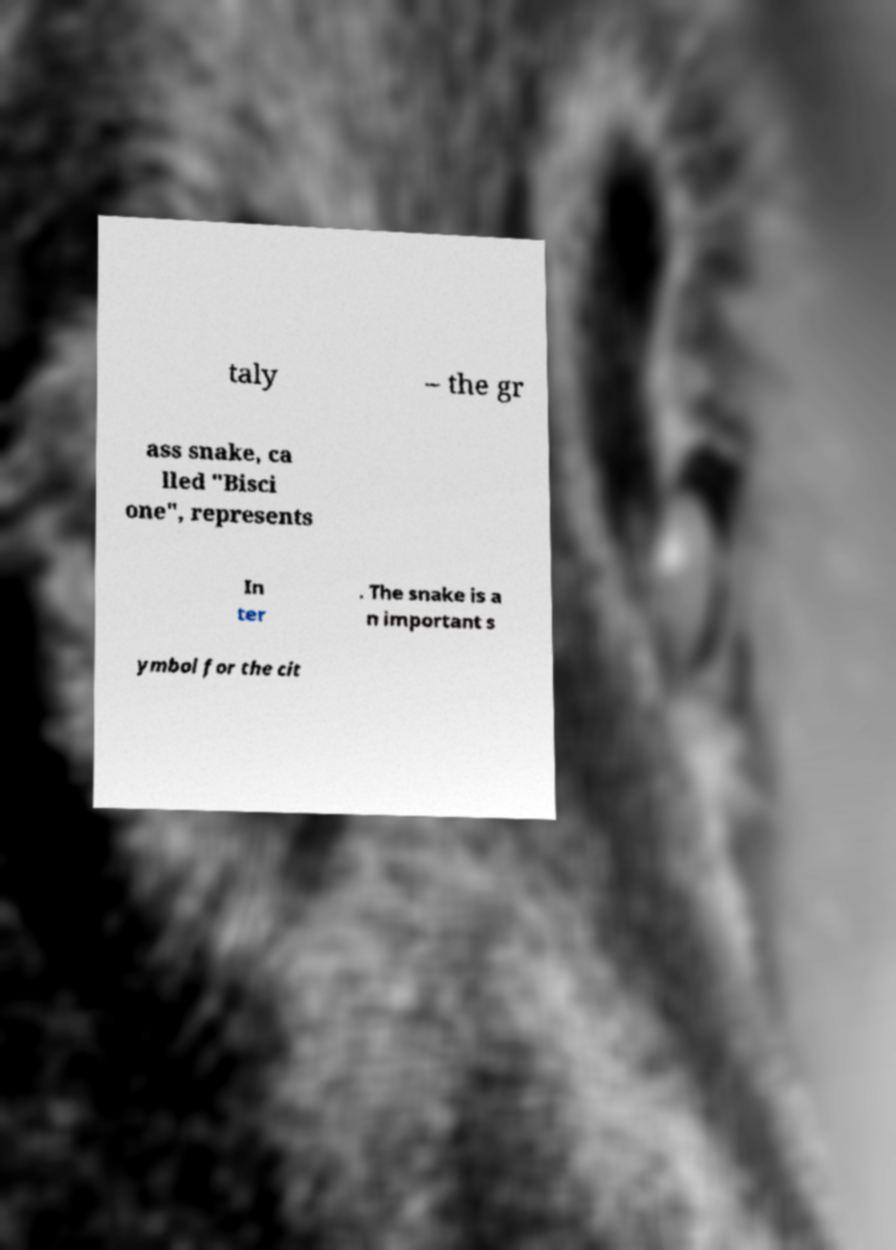Can you read and provide the text displayed in the image?This photo seems to have some interesting text. Can you extract and type it out for me? taly – the gr ass snake, ca lled "Bisci one", represents In ter . The snake is a n important s ymbol for the cit 